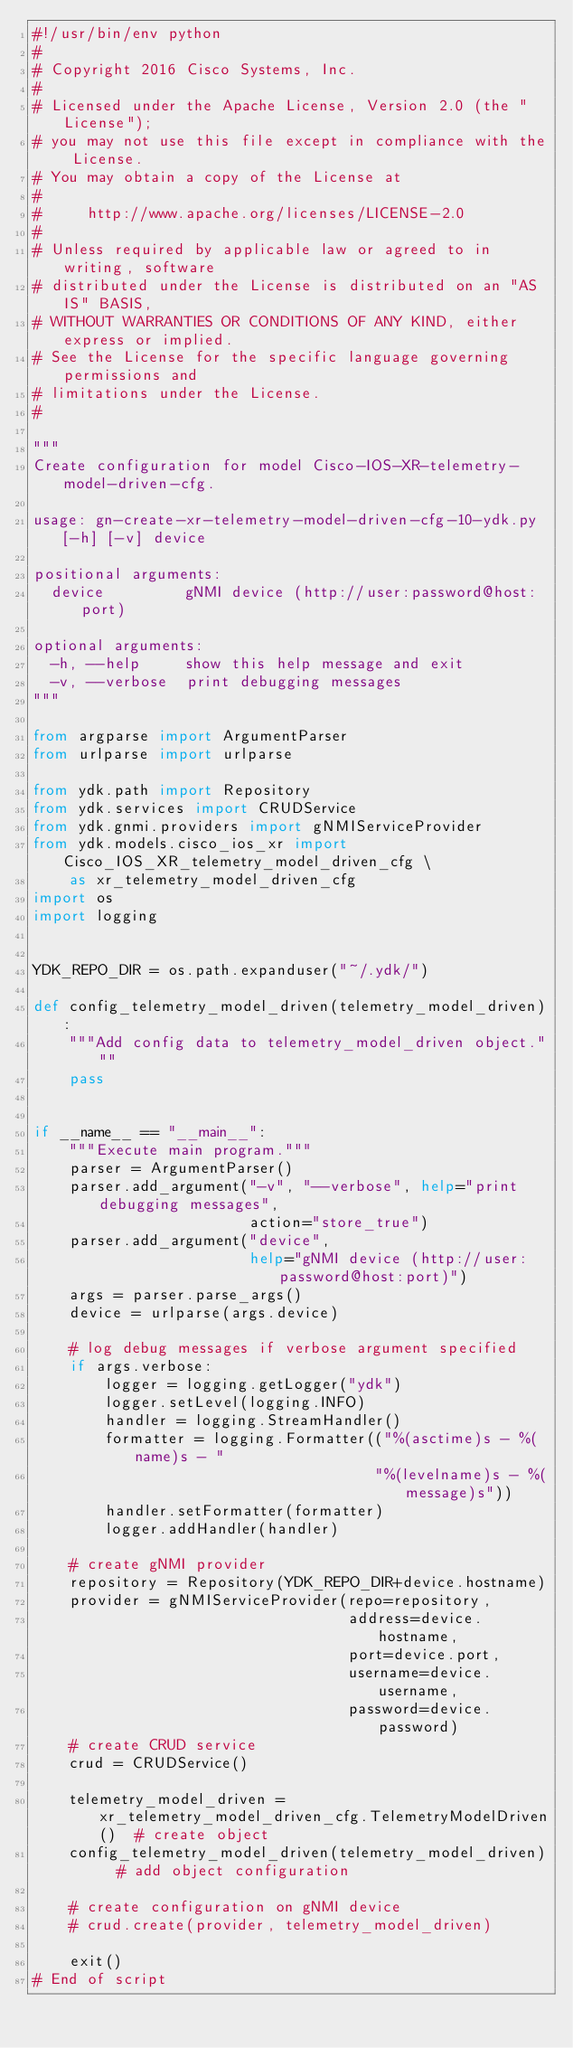Convert code to text. <code><loc_0><loc_0><loc_500><loc_500><_Python_>#!/usr/bin/env python
#
# Copyright 2016 Cisco Systems, Inc.
#
# Licensed under the Apache License, Version 2.0 (the "License");
# you may not use this file except in compliance with the License.
# You may obtain a copy of the License at
#
#     http://www.apache.org/licenses/LICENSE-2.0
#
# Unless required by applicable law or agreed to in writing, software
# distributed under the License is distributed on an "AS IS" BASIS,
# WITHOUT WARRANTIES OR CONDITIONS OF ANY KIND, either express or implied.
# See the License for the specific language governing permissions and
# limitations under the License.
#

"""
Create configuration for model Cisco-IOS-XR-telemetry-model-driven-cfg.

usage: gn-create-xr-telemetry-model-driven-cfg-10-ydk.py [-h] [-v] device

positional arguments:
  device         gNMI device (http://user:password@host:port)

optional arguments:
  -h, --help     show this help message and exit
  -v, --verbose  print debugging messages
"""

from argparse import ArgumentParser
from urlparse import urlparse

from ydk.path import Repository
from ydk.services import CRUDService
from ydk.gnmi.providers import gNMIServiceProvider
from ydk.models.cisco_ios_xr import Cisco_IOS_XR_telemetry_model_driven_cfg \
    as xr_telemetry_model_driven_cfg
import os
import logging


YDK_REPO_DIR = os.path.expanduser("~/.ydk/")

def config_telemetry_model_driven(telemetry_model_driven):
    """Add config data to telemetry_model_driven object."""
    pass


if __name__ == "__main__":
    """Execute main program."""
    parser = ArgumentParser()
    parser.add_argument("-v", "--verbose", help="print debugging messages",
                        action="store_true")
    parser.add_argument("device",
                        help="gNMI device (http://user:password@host:port)")
    args = parser.parse_args()
    device = urlparse(args.device)

    # log debug messages if verbose argument specified
    if args.verbose:
        logger = logging.getLogger("ydk")
        logger.setLevel(logging.INFO)
        handler = logging.StreamHandler()
        formatter = logging.Formatter(("%(asctime)s - %(name)s - "
                                      "%(levelname)s - %(message)s"))
        handler.setFormatter(formatter)
        logger.addHandler(handler)

    # create gNMI provider
    repository = Repository(YDK_REPO_DIR+device.hostname)
    provider = gNMIServiceProvider(repo=repository,
                                   address=device.hostname,
                                   port=device.port,
                                   username=device.username,
                                   password=device.password)
    # create CRUD service
    crud = CRUDService()

    telemetry_model_driven = xr_telemetry_model_driven_cfg.TelemetryModelDriven()  # create object
    config_telemetry_model_driven(telemetry_model_driven)  # add object configuration

    # create configuration on gNMI device
    # crud.create(provider, telemetry_model_driven)

    exit()
# End of script
</code> 